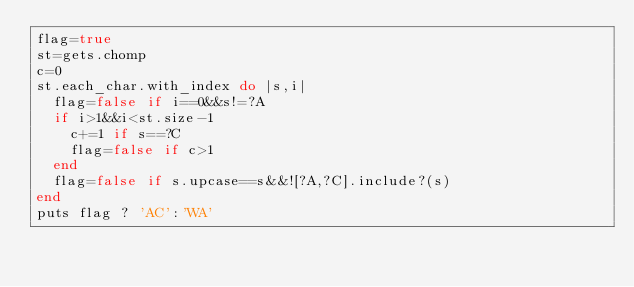<code> <loc_0><loc_0><loc_500><loc_500><_Ruby_>flag=true
st=gets.chomp
c=0
st.each_char.with_index do |s,i|
  flag=false if i==0&&s!=?A
  if i>1&&i<st.size-1
    c+=1 if s==?C
    flag=false if c>1
  end
  flag=false if s.upcase==s&&![?A,?C].include?(s)
end
puts flag ? 'AC':'WA'
</code> 